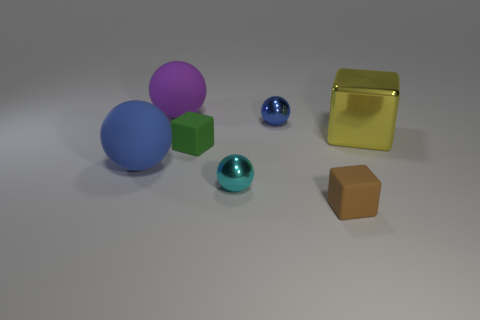Subtract all blue balls. Subtract all green cylinders. How many balls are left? 2 Add 3 yellow blocks. How many objects exist? 10 Subtract all spheres. How many objects are left? 3 Add 2 yellow things. How many yellow things are left? 3 Add 5 big gray matte cubes. How many big gray matte cubes exist? 5 Subtract 0 green balls. How many objects are left? 7 Subtract all small green rubber blocks. Subtract all matte spheres. How many objects are left? 4 